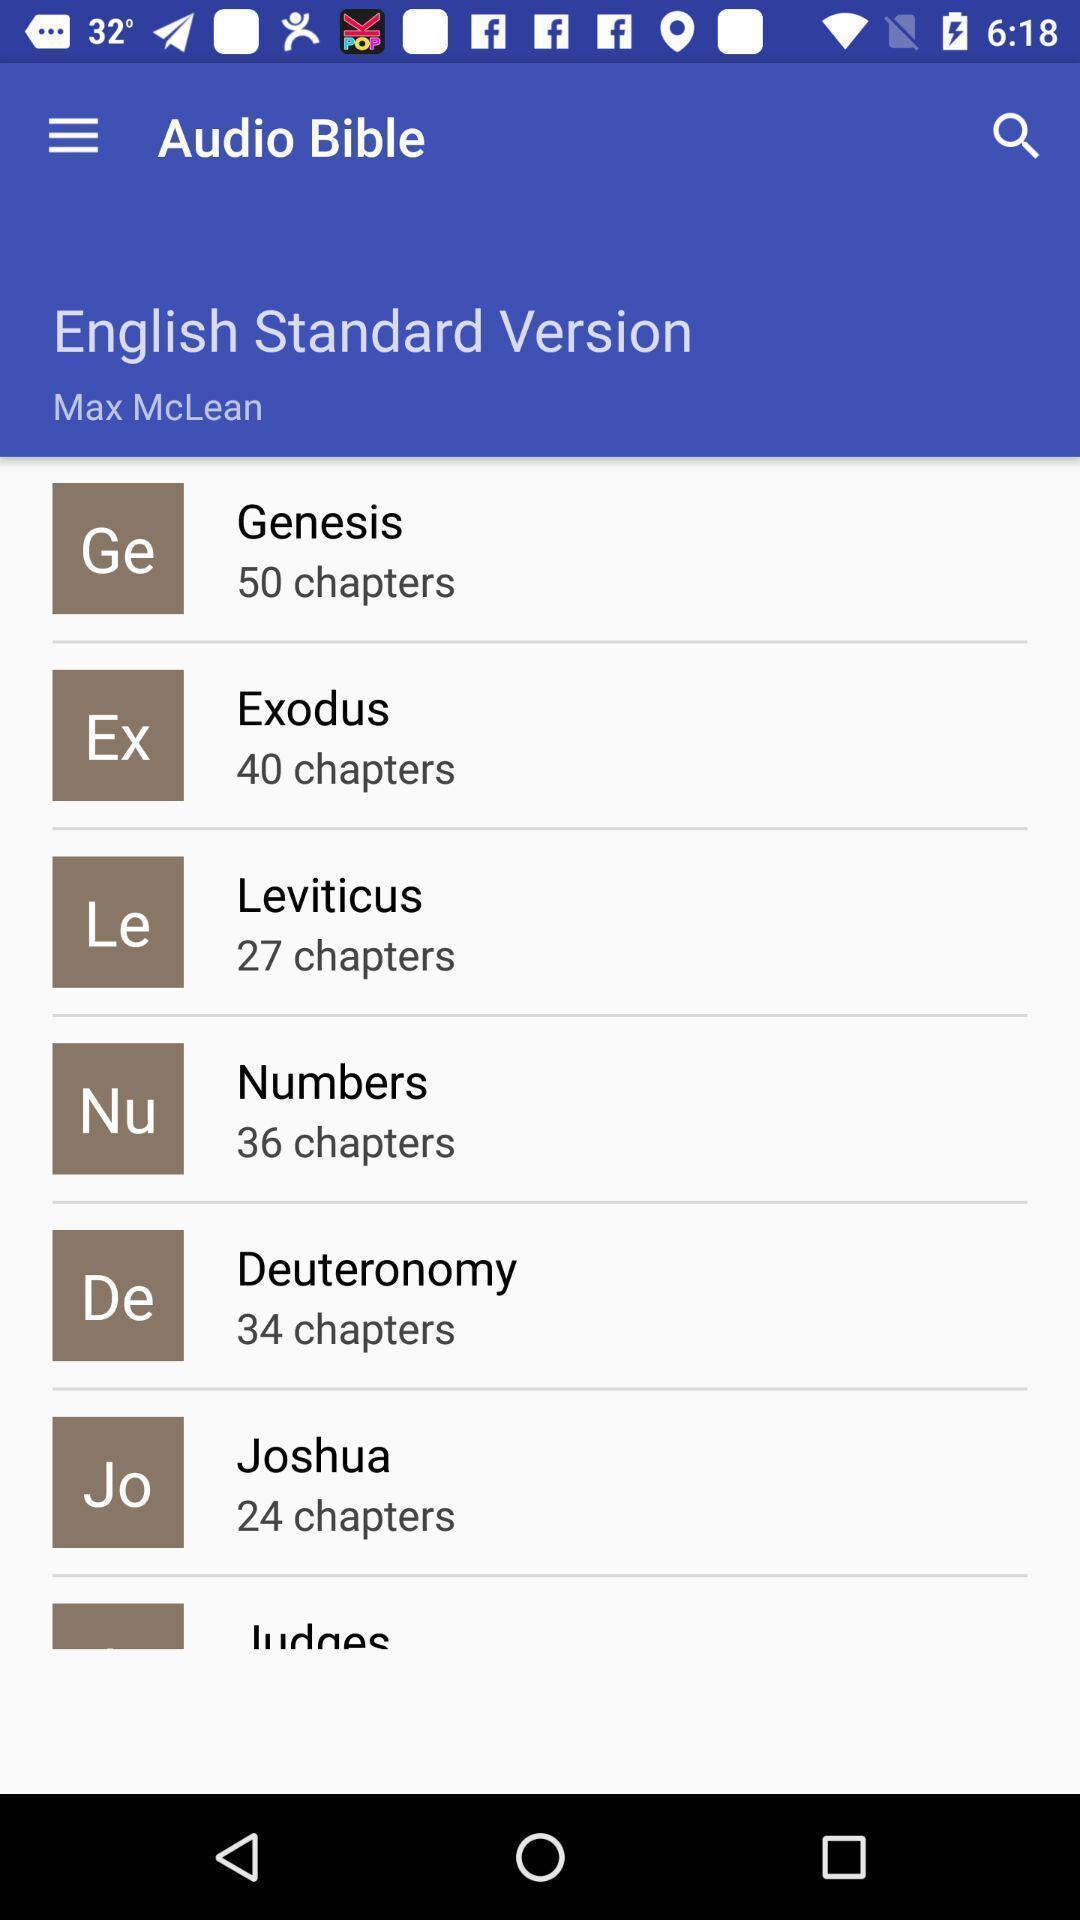Summarize the main components in this picture. Page showing different options in audio bible. 